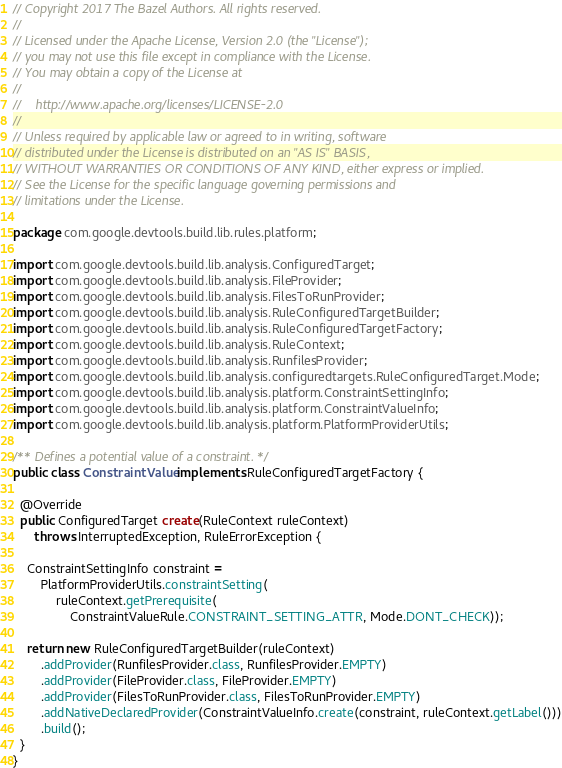<code> <loc_0><loc_0><loc_500><loc_500><_Java_>// Copyright 2017 The Bazel Authors. All rights reserved.
//
// Licensed under the Apache License, Version 2.0 (the "License");
// you may not use this file except in compliance with the License.
// You may obtain a copy of the License at
//
//    http://www.apache.org/licenses/LICENSE-2.0
//
// Unless required by applicable law or agreed to in writing, software
// distributed under the License is distributed on an "AS IS" BASIS,
// WITHOUT WARRANTIES OR CONDITIONS OF ANY KIND, either express or implied.
// See the License for the specific language governing permissions and
// limitations under the License.

package com.google.devtools.build.lib.rules.platform;

import com.google.devtools.build.lib.analysis.ConfiguredTarget;
import com.google.devtools.build.lib.analysis.FileProvider;
import com.google.devtools.build.lib.analysis.FilesToRunProvider;
import com.google.devtools.build.lib.analysis.RuleConfiguredTargetBuilder;
import com.google.devtools.build.lib.analysis.RuleConfiguredTargetFactory;
import com.google.devtools.build.lib.analysis.RuleContext;
import com.google.devtools.build.lib.analysis.RunfilesProvider;
import com.google.devtools.build.lib.analysis.configuredtargets.RuleConfiguredTarget.Mode;
import com.google.devtools.build.lib.analysis.platform.ConstraintSettingInfo;
import com.google.devtools.build.lib.analysis.platform.ConstraintValueInfo;
import com.google.devtools.build.lib.analysis.platform.PlatformProviderUtils;

/** Defines a potential value of a constraint. */
public class ConstraintValue implements RuleConfiguredTargetFactory {

  @Override
  public ConfiguredTarget create(RuleContext ruleContext)
      throws InterruptedException, RuleErrorException {

    ConstraintSettingInfo constraint =
        PlatformProviderUtils.constraintSetting(
            ruleContext.getPrerequisite(
                ConstraintValueRule.CONSTRAINT_SETTING_ATTR, Mode.DONT_CHECK));

    return new RuleConfiguredTargetBuilder(ruleContext)
        .addProvider(RunfilesProvider.class, RunfilesProvider.EMPTY)
        .addProvider(FileProvider.class, FileProvider.EMPTY)
        .addProvider(FilesToRunProvider.class, FilesToRunProvider.EMPTY)
        .addNativeDeclaredProvider(ConstraintValueInfo.create(constraint, ruleContext.getLabel()))
        .build();
  }
}
</code> 